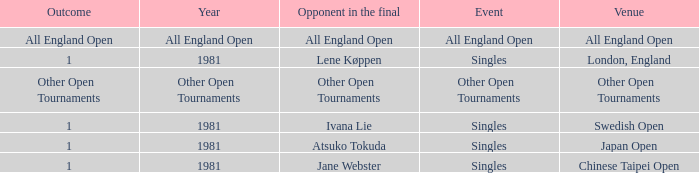What Event has an Outcome of other open tournaments? Other Open Tournaments. 